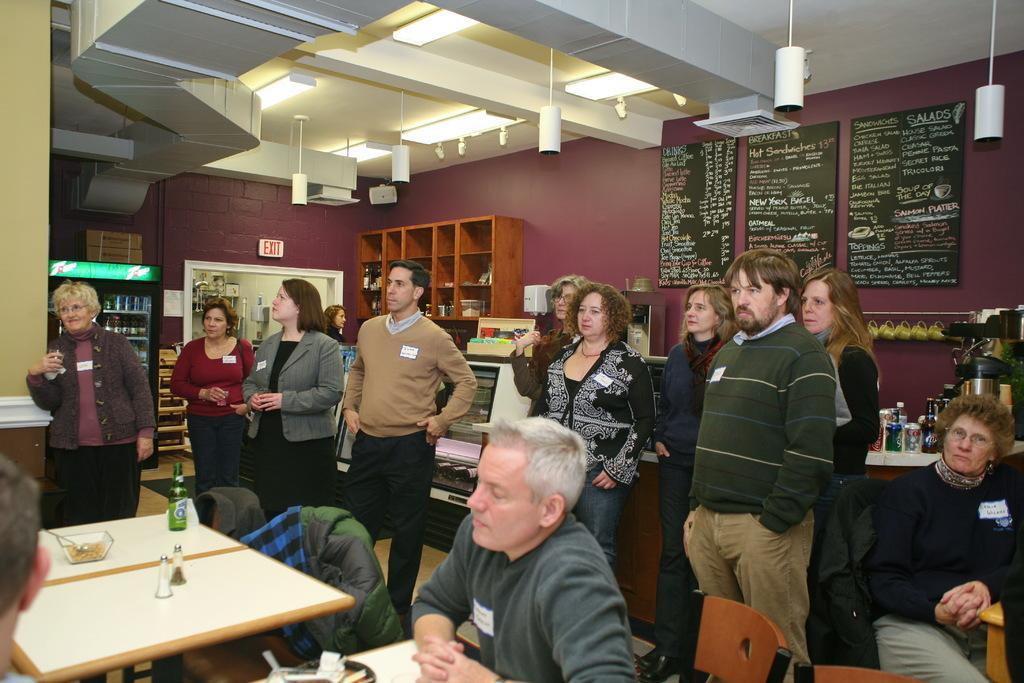How would you summarize this image in a sentence or two? In this image I can see the group of people standing and some are sitting in-front of the table. On the table there is a bottle. In the back there is a cupboard,boards attached to the wall and some of the objects. 